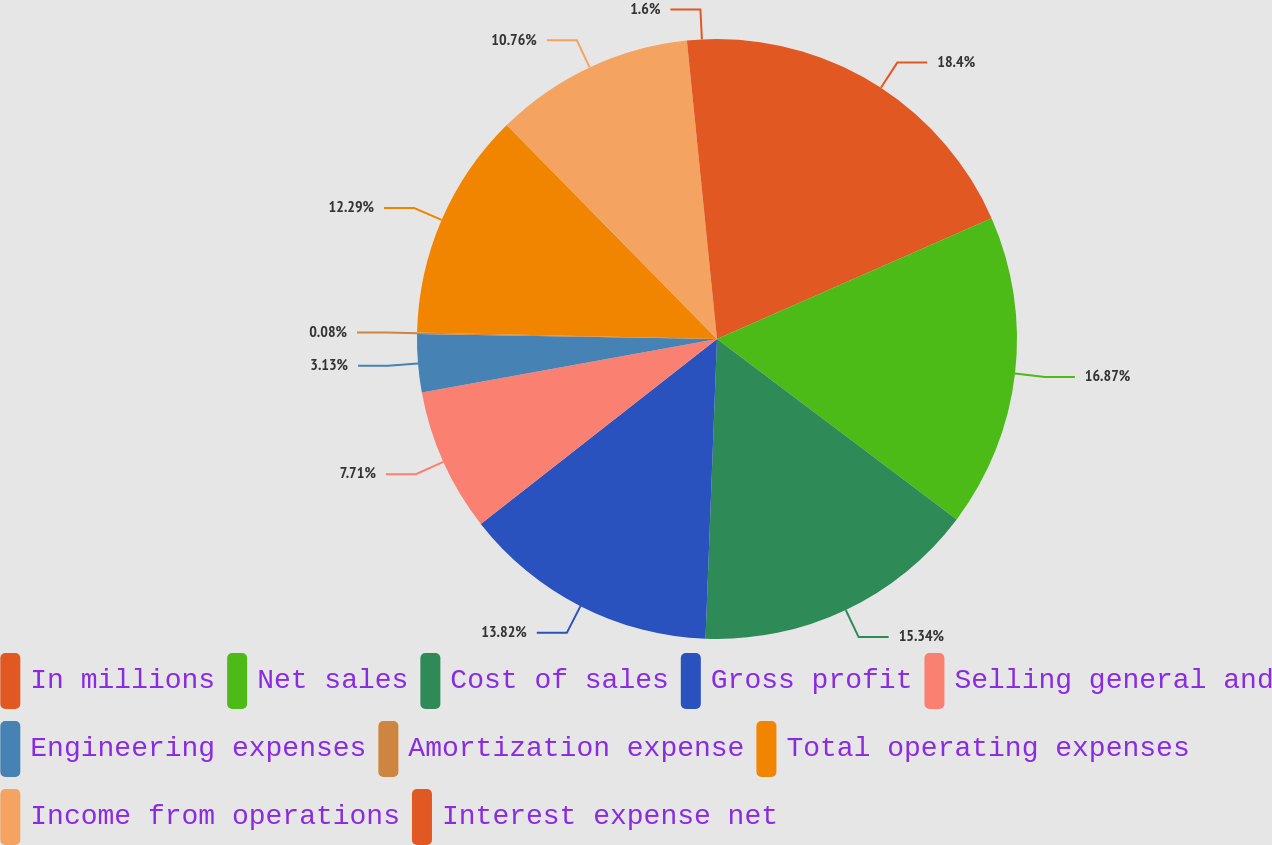<chart> <loc_0><loc_0><loc_500><loc_500><pie_chart><fcel>In millions<fcel>Net sales<fcel>Cost of sales<fcel>Gross profit<fcel>Selling general and<fcel>Engineering expenses<fcel>Amortization expense<fcel>Total operating expenses<fcel>Income from operations<fcel>Interest expense net<nl><fcel>18.4%<fcel>16.87%<fcel>15.34%<fcel>13.82%<fcel>7.71%<fcel>3.13%<fcel>0.08%<fcel>12.29%<fcel>10.76%<fcel>1.6%<nl></chart> 